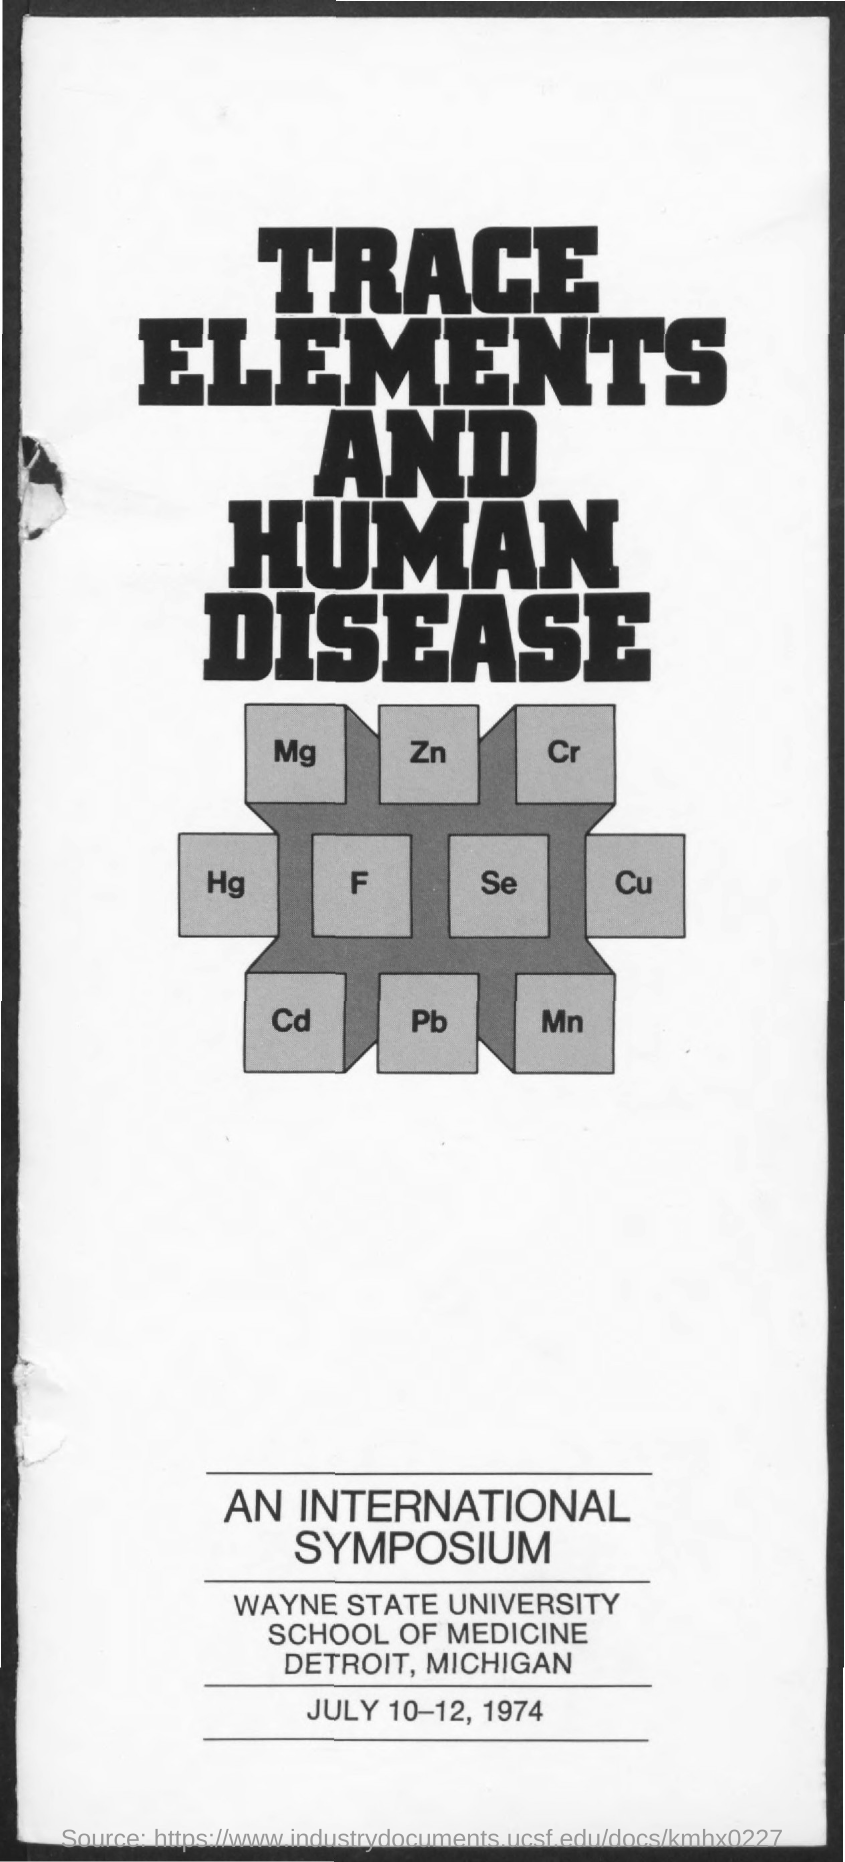What is written in big bold letters?
Your answer should be compact. TRACE ELEMENTS AND HUMAN DISEASE. What is the name of the university?
Give a very brief answer. Wayne State University. What is the date mentioned at the bottom?
Provide a short and direct response. JULY 10-12, 1974. Where is the WAYNE STATE UNIVERSITY located?
Provide a succinct answer. DETROIT, MICHIGAN. 